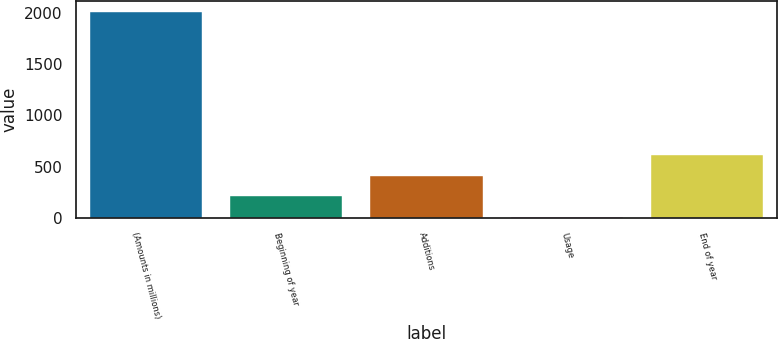<chart> <loc_0><loc_0><loc_500><loc_500><bar_chart><fcel>(Amounts in millions)<fcel>Beginning of year<fcel>Additions<fcel>Usage<fcel>End of year<nl><fcel>2010<fcel>213.06<fcel>412.72<fcel>13.4<fcel>612.38<nl></chart> 